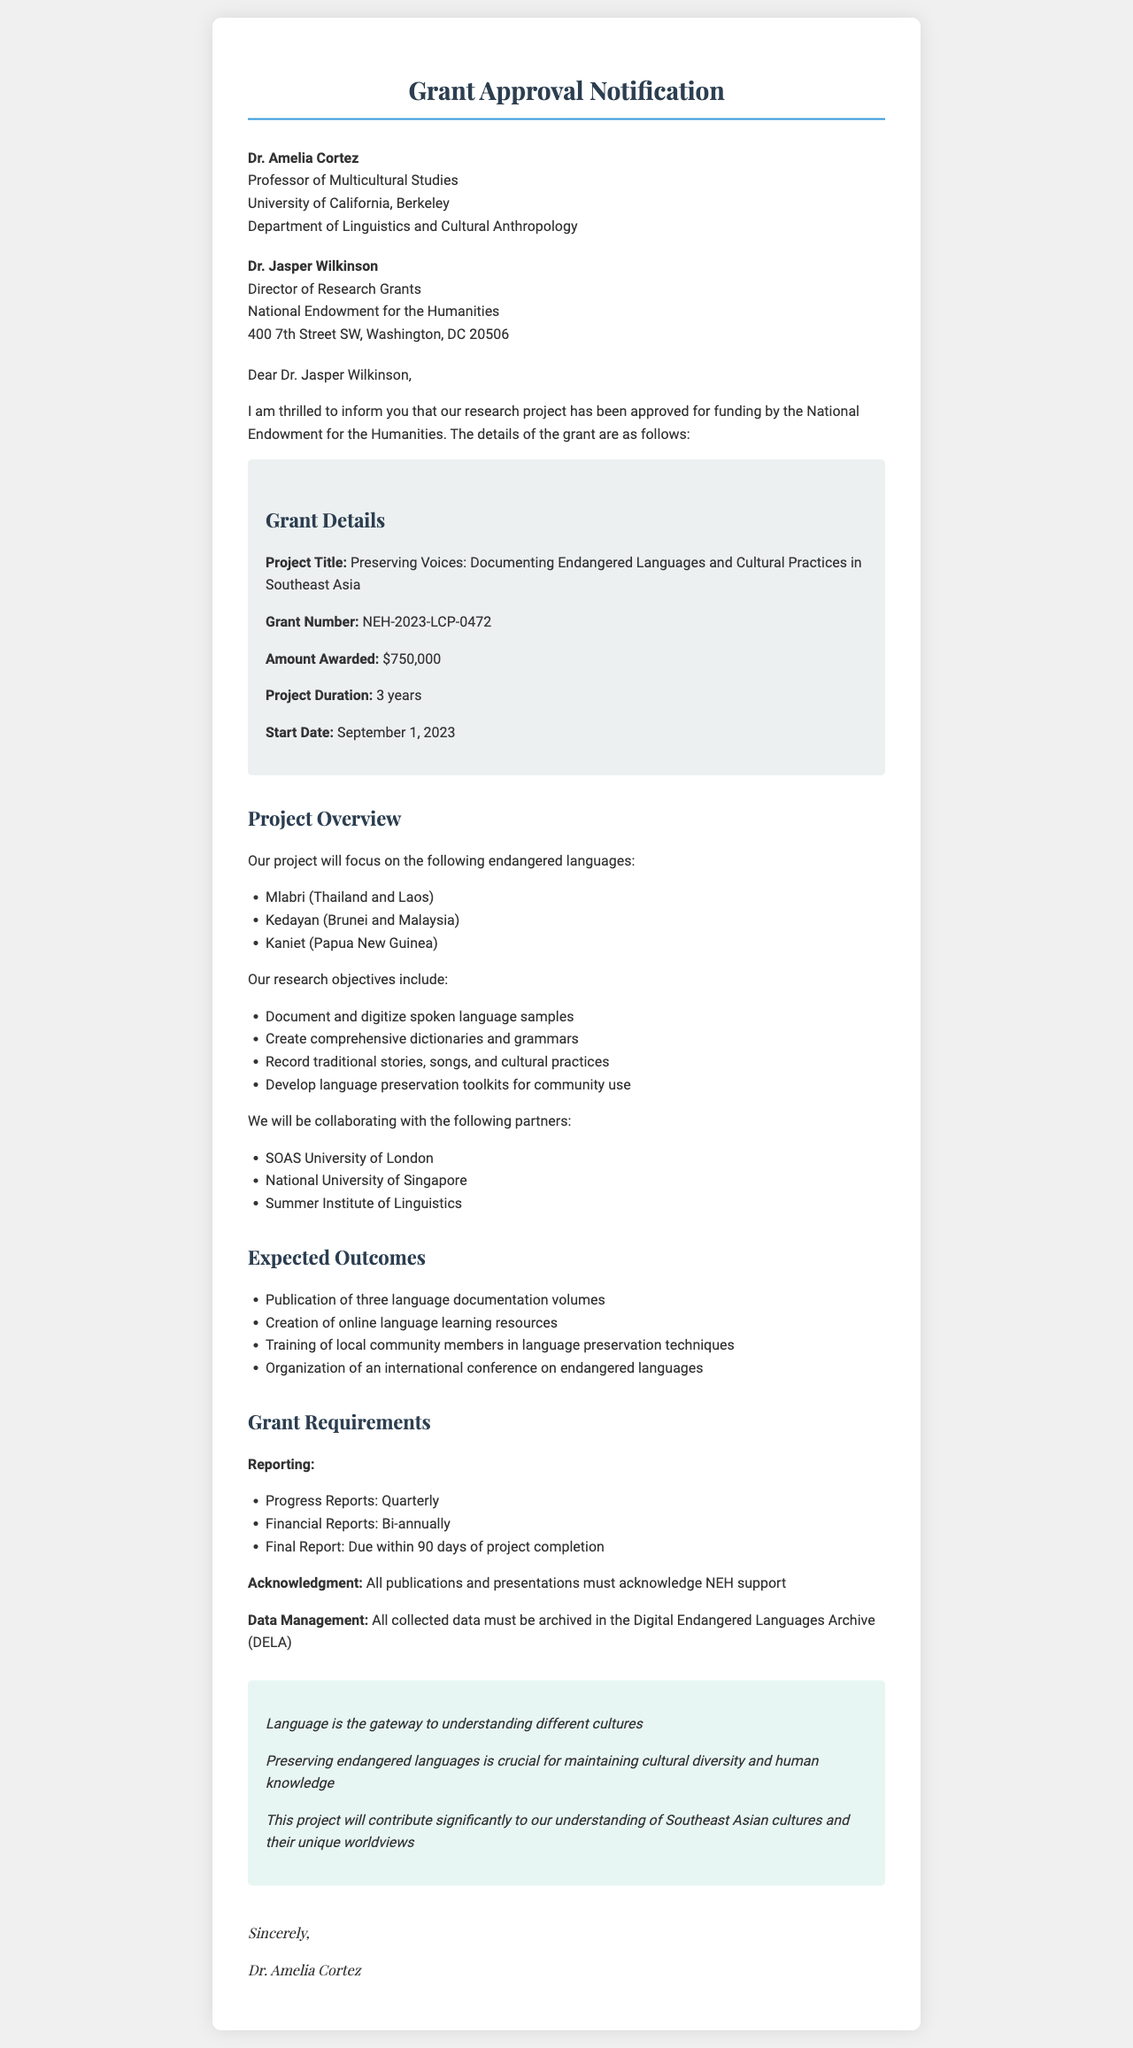What is the project title? The project title is explicitly stated in the grant details section of the document.
Answer: Preserving Voices: Documenting Endangered Languages and Cultural Practices in Southeast Asia How much funding was awarded? The amount awarded is specified under the grant details section of the document.
Answer: $750,000 What is the start date of the project? The start date is explicitly mentioned in the grant details section of the document.
Answer: September 1, 2023 What are the focus languages of the project? The document lists the specific languages that the project will focus on.
Answer: Mlabri, Kedayan, Kaniet How long is the project duration? The project duration is stated in the grant details section of the document.
Answer: 3 years What are one of the expected outcomes of the project? Expected outcomes are listed and can be referenced directly from the document.
Answer: Publication of three language documentation volumes Who is the sender of the letter? The sender's information is provided near the beginning of the document.
Answer: Dr. Amelia Cortez What is required for data management according to the grant requirements? The document outlines specific requirements for data management.
Answer: Archive in the Digital Endangered Languages Archive (DELA) What is the main belief expressed in the personal statement? The personal statement conveys Dr. Cortez's belief as outlined in the document.
Answer: Language is the gateway to understanding different cultures 